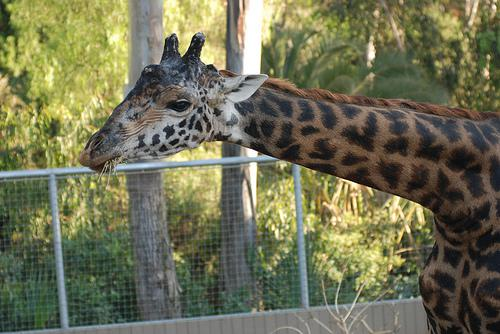Question: what is the giraffe doing?
Choices:
A. Sleeping.
B. Running.
C. Drinking.
D. Eating.
Answer with the letter. Answer: D Question: why is it so bright?
Choices:
A. Sunny.
B. The light is on.
C. The reflection.
D. The white paint.
Answer with the letter. Answer: A Question: what is in the giraffe's mouth?
Choices:
A. Grain.
B. Grass.
C. Corn.
D. Leaves.
Answer with the letter. Answer: B Question: what is behind the giraffe?
Choices:
A. Trees.
B. Fence.
C. Shed.
D. Hill.
Answer with the letter. Answer: A Question: where was the photo taken?
Choices:
A. The safari.
B. The dance.
C. The beach.
D. At the zoo.
Answer with the letter. Answer: D Question: what is in the photo?
Choices:
A. A giraffe.
B. An elephant.
C. A goat.
D. A cat.
Answer with the letter. Answer: A 